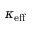Convert formula to latex. <formula><loc_0><loc_0><loc_500><loc_500>\kappa _ { e f f }</formula> 